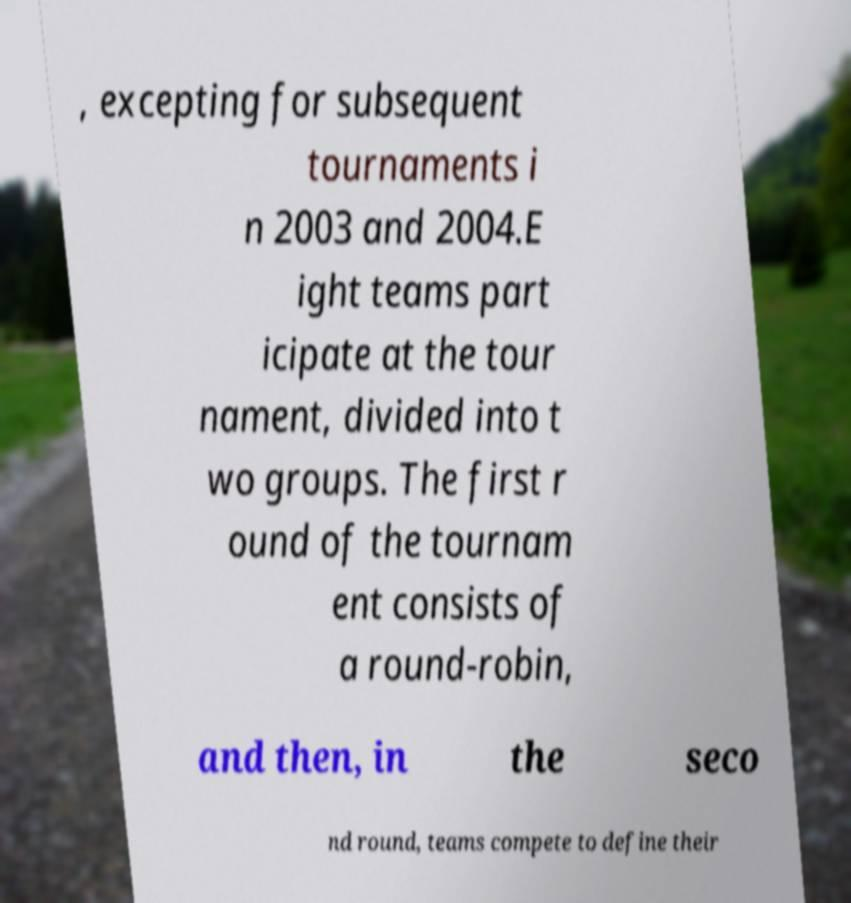Could you extract and type out the text from this image? , excepting for subsequent tournaments i n 2003 and 2004.E ight teams part icipate at the tour nament, divided into t wo groups. The first r ound of the tournam ent consists of a round-robin, and then, in the seco nd round, teams compete to define their 